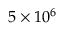<formula> <loc_0><loc_0><loc_500><loc_500>5 \times 1 0 ^ { 6 }</formula> 